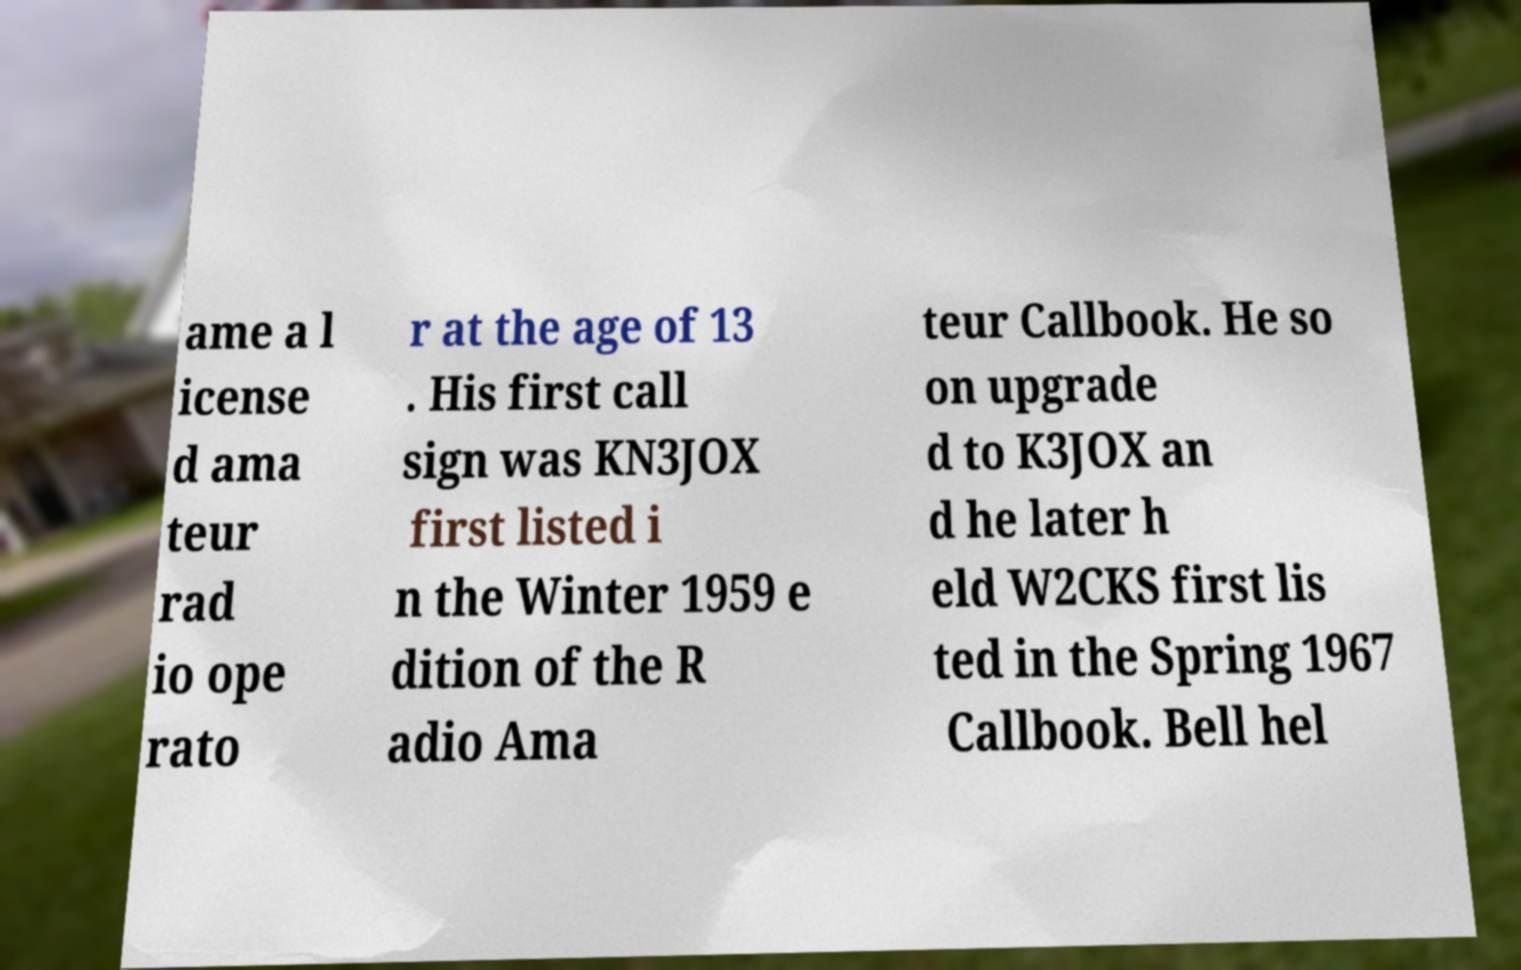What messages or text are displayed in this image? I need them in a readable, typed format. ame a l icense d ama teur rad io ope rato r at the age of 13 . His first call sign was KN3JOX first listed i n the Winter 1959 e dition of the R adio Ama teur Callbook. He so on upgrade d to K3JOX an d he later h eld W2CKS first lis ted in the Spring 1967 Callbook. Bell hel 